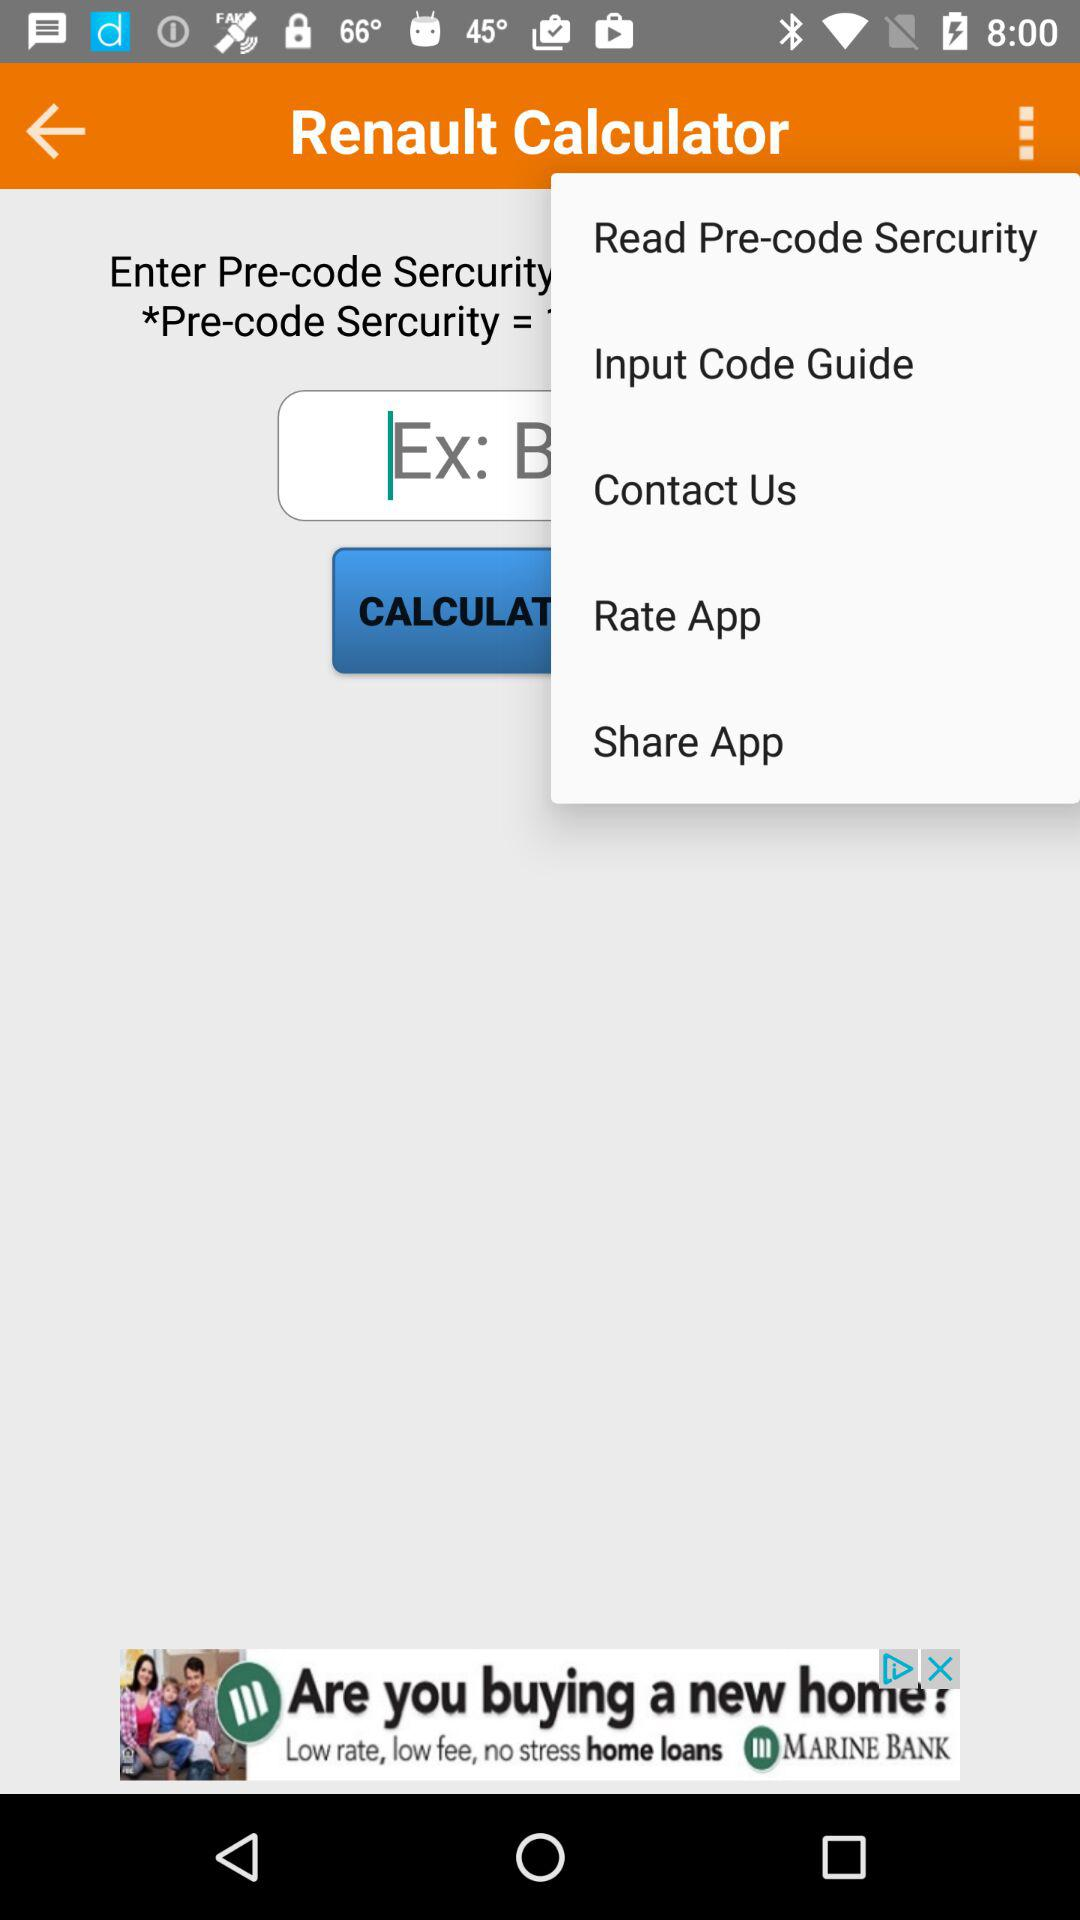What is the application name? The application name is "Renault Calculator". 